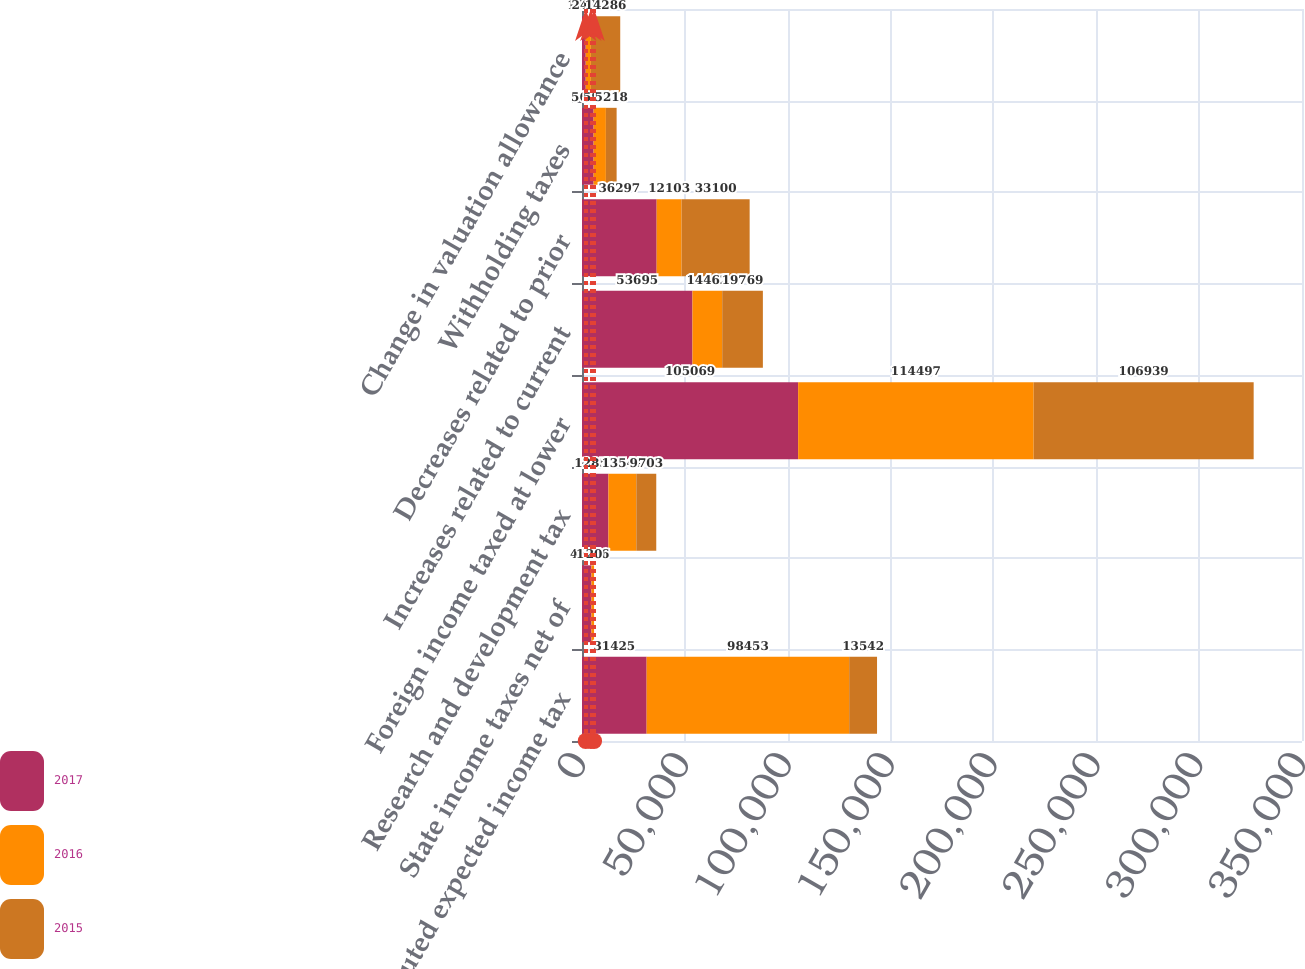<chart> <loc_0><loc_0><loc_500><loc_500><stacked_bar_chart><ecel><fcel>Computed expected income tax<fcel>State income taxes net of<fcel>Research and development tax<fcel>Foreign income taxed at lower<fcel>Increases related to current<fcel>Decreases related to prior<fcel>Withholding taxes<fcel>Change in valuation allowance<nl><fcel>2017<fcel>31425<fcel>4609<fcel>12852<fcel>105069<fcel>53695<fcel>36297<fcel>5643<fcel>1814<nl><fcel>2016<fcel>98453<fcel>1246<fcel>13542<fcel>114497<fcel>14462<fcel>12103<fcel>5970<fcel>2482<nl><fcel>2015<fcel>13542<fcel>20<fcel>9703<fcel>106939<fcel>19769<fcel>33100<fcel>5218<fcel>14286<nl></chart> 